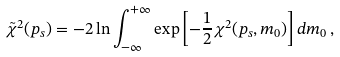Convert formula to latex. <formula><loc_0><loc_0><loc_500><loc_500>\tilde { \chi } ^ { 2 } ( p _ { s } ) = - 2 \ln \int _ { - \infty } ^ { + \infty } \exp \left [ - \frac { 1 } { 2 } \chi ^ { 2 } ( p _ { s } , m _ { 0 } ) \right ] d m _ { 0 } \, ,</formula> 